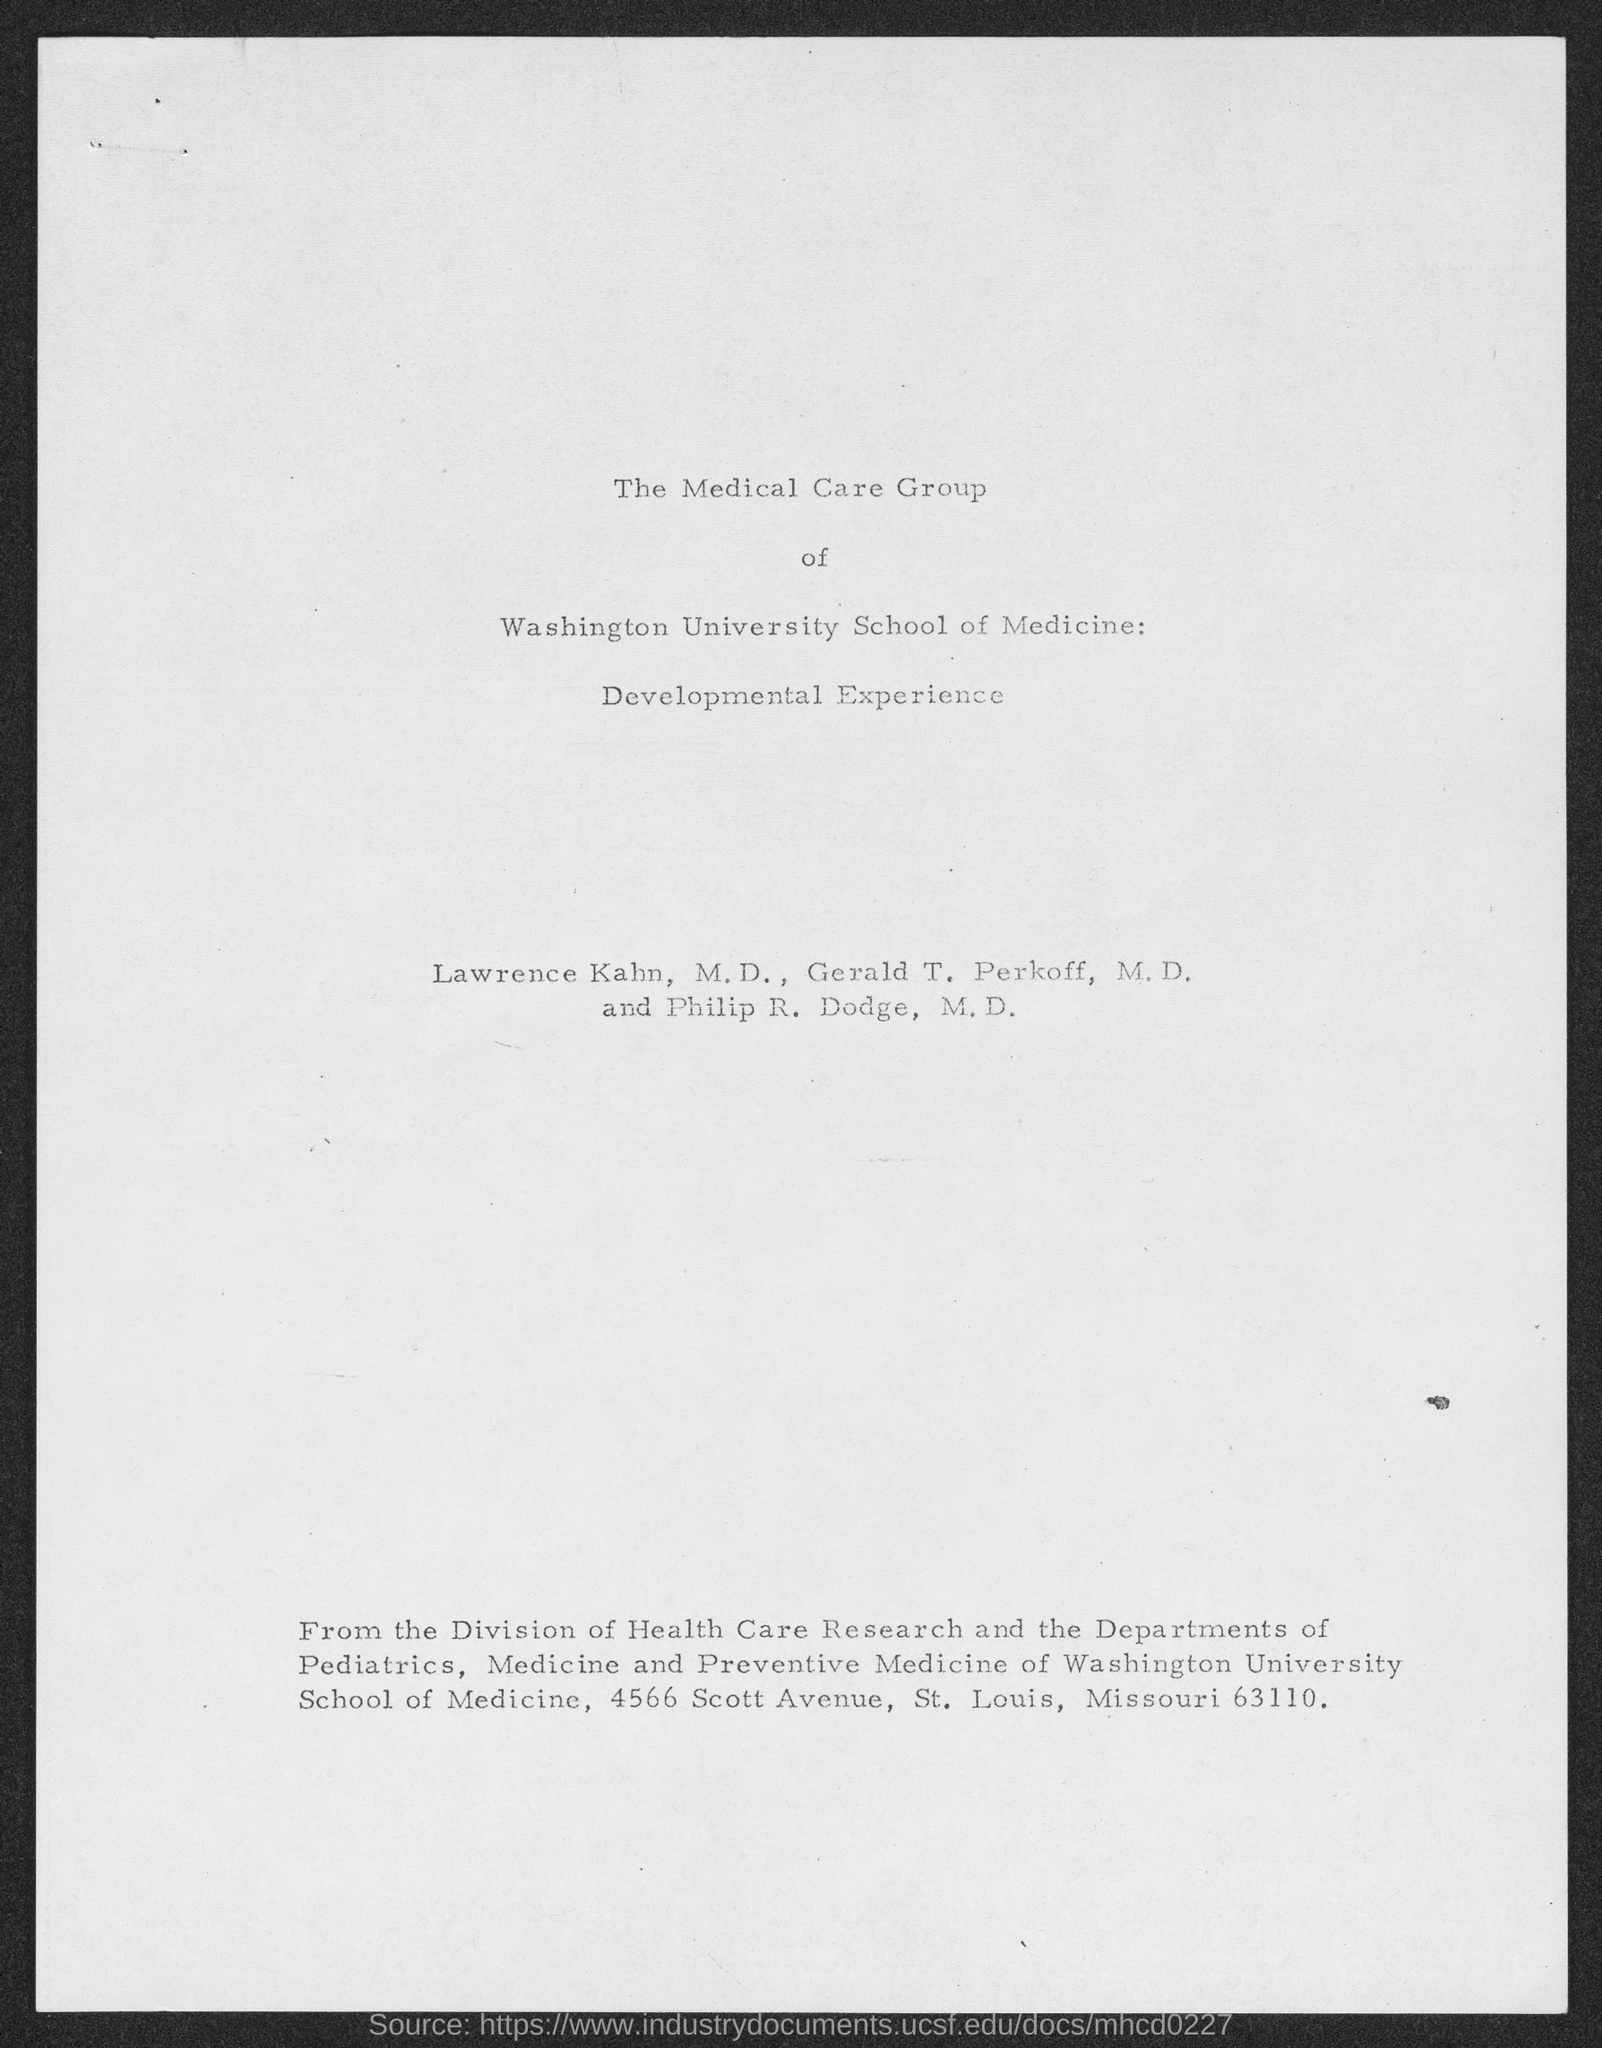Outline some significant characteristics in this image. Medicine and Preventive Medicine of Washington University School of Medicine has a street address of 4566 Scott Avenue. 